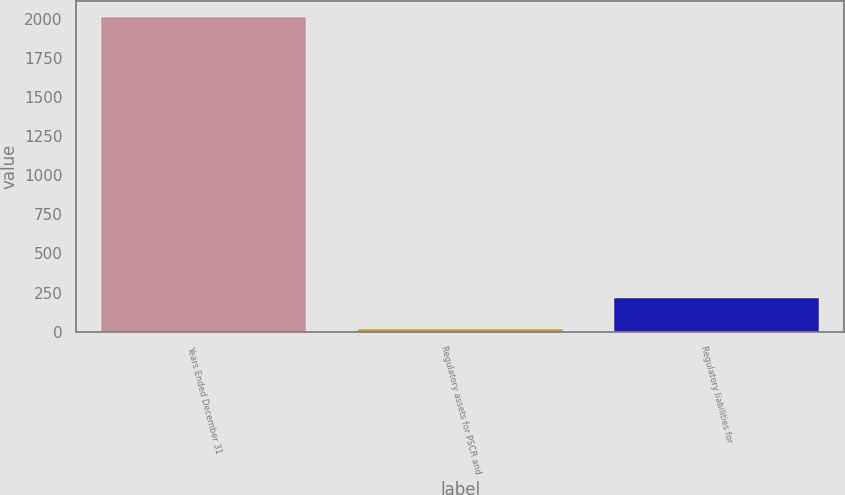Convert chart to OTSL. <chart><loc_0><loc_0><loc_500><loc_500><bar_chart><fcel>Years Ended December 31<fcel>Regulatory assets for PSCR and<fcel>Regulatory liabilities for<nl><fcel>2010<fcel>15<fcel>214.5<nl></chart> 